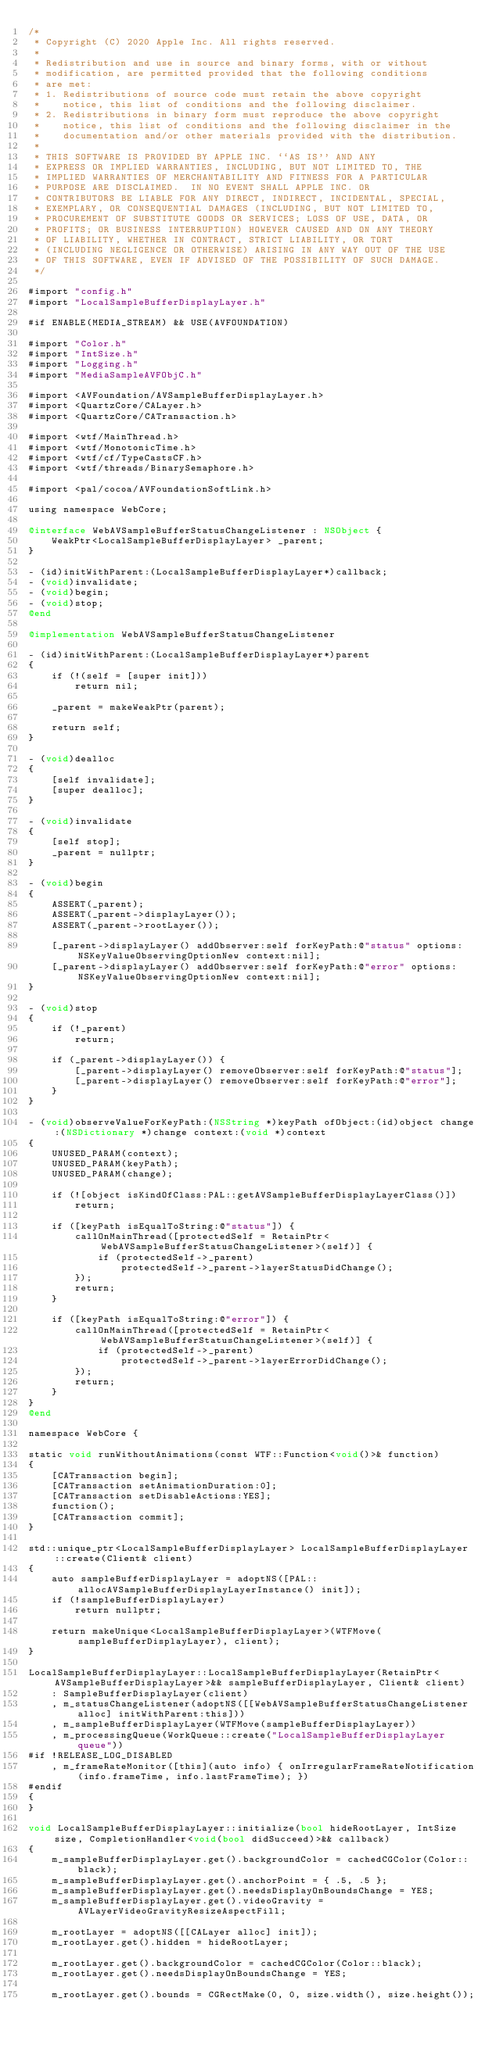Convert code to text. <code><loc_0><loc_0><loc_500><loc_500><_ObjectiveC_>/*
 * Copyright (C) 2020 Apple Inc. All rights reserved.
 *
 * Redistribution and use in source and binary forms, with or without
 * modification, are permitted provided that the following conditions
 * are met:
 * 1. Redistributions of source code must retain the above copyright
 *    notice, this list of conditions and the following disclaimer.
 * 2. Redistributions in binary form must reproduce the above copyright
 *    notice, this list of conditions and the following disclaimer in the
 *    documentation and/or other materials provided with the distribution.
 *
 * THIS SOFTWARE IS PROVIDED BY APPLE INC. ``AS IS'' AND ANY
 * EXPRESS OR IMPLIED WARRANTIES, INCLUDING, BUT NOT LIMITED TO, THE
 * IMPLIED WARRANTIES OF MERCHANTABILITY AND FITNESS FOR A PARTICULAR
 * PURPOSE ARE DISCLAIMED.  IN NO EVENT SHALL APPLE INC. OR
 * CONTRIBUTORS BE LIABLE FOR ANY DIRECT, INDIRECT, INCIDENTAL, SPECIAL,
 * EXEMPLARY, OR CONSEQUENTIAL DAMAGES (INCLUDING, BUT NOT LIMITED TO,
 * PROCUREMENT OF SUBSTITUTE GOODS OR SERVICES; LOSS OF USE, DATA, OR
 * PROFITS; OR BUSINESS INTERRUPTION) HOWEVER CAUSED AND ON ANY THEORY
 * OF LIABILITY, WHETHER IN CONTRACT, STRICT LIABILITY, OR TORT
 * (INCLUDING NEGLIGENCE OR OTHERWISE) ARISING IN ANY WAY OUT OF THE USE
 * OF THIS SOFTWARE, EVEN IF ADVISED OF THE POSSIBILITY OF SUCH DAMAGE.
 */

#import "config.h"
#import "LocalSampleBufferDisplayLayer.h"

#if ENABLE(MEDIA_STREAM) && USE(AVFOUNDATION)

#import "Color.h"
#import "IntSize.h"
#import "Logging.h"
#import "MediaSampleAVFObjC.h"

#import <AVFoundation/AVSampleBufferDisplayLayer.h>
#import <QuartzCore/CALayer.h>
#import <QuartzCore/CATransaction.h>

#import <wtf/MainThread.h>
#import <wtf/MonotonicTime.h>
#import <wtf/cf/TypeCastsCF.h>
#import <wtf/threads/BinarySemaphore.h>

#import <pal/cocoa/AVFoundationSoftLink.h>

using namespace WebCore;

@interface WebAVSampleBufferStatusChangeListener : NSObject {
    WeakPtr<LocalSampleBufferDisplayLayer> _parent;
}

- (id)initWithParent:(LocalSampleBufferDisplayLayer*)callback;
- (void)invalidate;
- (void)begin;
- (void)stop;
@end

@implementation WebAVSampleBufferStatusChangeListener

- (id)initWithParent:(LocalSampleBufferDisplayLayer*)parent
{
    if (!(self = [super init]))
        return nil;

    _parent = makeWeakPtr(parent);

    return self;
}

- (void)dealloc
{
    [self invalidate];
    [super dealloc];
}

- (void)invalidate
{
    [self stop];
    _parent = nullptr;
}

- (void)begin
{
    ASSERT(_parent);
    ASSERT(_parent->displayLayer());
    ASSERT(_parent->rootLayer());

    [_parent->displayLayer() addObserver:self forKeyPath:@"status" options:NSKeyValueObservingOptionNew context:nil];
    [_parent->displayLayer() addObserver:self forKeyPath:@"error" options:NSKeyValueObservingOptionNew context:nil];
}

- (void)stop
{
    if (!_parent)
        return;

    if (_parent->displayLayer()) {
        [_parent->displayLayer() removeObserver:self forKeyPath:@"status"];
        [_parent->displayLayer() removeObserver:self forKeyPath:@"error"];
    }
}

- (void)observeValueForKeyPath:(NSString *)keyPath ofObject:(id)object change:(NSDictionary *)change context:(void *)context
{
    UNUSED_PARAM(context);
    UNUSED_PARAM(keyPath);
    UNUSED_PARAM(change);

    if (![object isKindOfClass:PAL::getAVSampleBufferDisplayLayerClass()])
        return;

    if ([keyPath isEqualToString:@"status"]) {
        callOnMainThread([protectedSelf = RetainPtr<WebAVSampleBufferStatusChangeListener>(self)] {
            if (protectedSelf->_parent)
                protectedSelf->_parent->layerStatusDidChange();
        });
        return;
    }

    if ([keyPath isEqualToString:@"error"]) {
        callOnMainThread([protectedSelf = RetainPtr<WebAVSampleBufferStatusChangeListener>(self)] {
            if (protectedSelf->_parent)
                protectedSelf->_parent->layerErrorDidChange();
        });
        return;
    }
}
@end

namespace WebCore {

static void runWithoutAnimations(const WTF::Function<void()>& function)
{
    [CATransaction begin];
    [CATransaction setAnimationDuration:0];
    [CATransaction setDisableActions:YES];
    function();
    [CATransaction commit];
}

std::unique_ptr<LocalSampleBufferDisplayLayer> LocalSampleBufferDisplayLayer::create(Client& client)
{
    auto sampleBufferDisplayLayer = adoptNS([PAL::allocAVSampleBufferDisplayLayerInstance() init]);
    if (!sampleBufferDisplayLayer)
        return nullptr;

    return makeUnique<LocalSampleBufferDisplayLayer>(WTFMove(sampleBufferDisplayLayer), client);
}

LocalSampleBufferDisplayLayer::LocalSampleBufferDisplayLayer(RetainPtr<AVSampleBufferDisplayLayer>&& sampleBufferDisplayLayer, Client& client)
    : SampleBufferDisplayLayer(client)
    , m_statusChangeListener(adoptNS([[WebAVSampleBufferStatusChangeListener alloc] initWithParent:this]))
    , m_sampleBufferDisplayLayer(WTFMove(sampleBufferDisplayLayer))
    , m_processingQueue(WorkQueue::create("LocalSampleBufferDisplayLayer queue"))
#if !RELEASE_LOG_DISABLED
    , m_frameRateMonitor([this](auto info) { onIrregularFrameRateNotification(info.frameTime, info.lastFrameTime); })
#endif
{
}

void LocalSampleBufferDisplayLayer::initialize(bool hideRootLayer, IntSize size, CompletionHandler<void(bool didSucceed)>&& callback)
{
    m_sampleBufferDisplayLayer.get().backgroundColor = cachedCGColor(Color::black);
    m_sampleBufferDisplayLayer.get().anchorPoint = { .5, .5 };
    m_sampleBufferDisplayLayer.get().needsDisplayOnBoundsChange = YES;
    m_sampleBufferDisplayLayer.get().videoGravity = AVLayerVideoGravityResizeAspectFill;

    m_rootLayer = adoptNS([[CALayer alloc] init]);
    m_rootLayer.get().hidden = hideRootLayer;

    m_rootLayer.get().backgroundColor = cachedCGColor(Color::black);
    m_rootLayer.get().needsDisplayOnBoundsChange = YES;

    m_rootLayer.get().bounds = CGRectMake(0, 0, size.width(), size.height());
</code> 